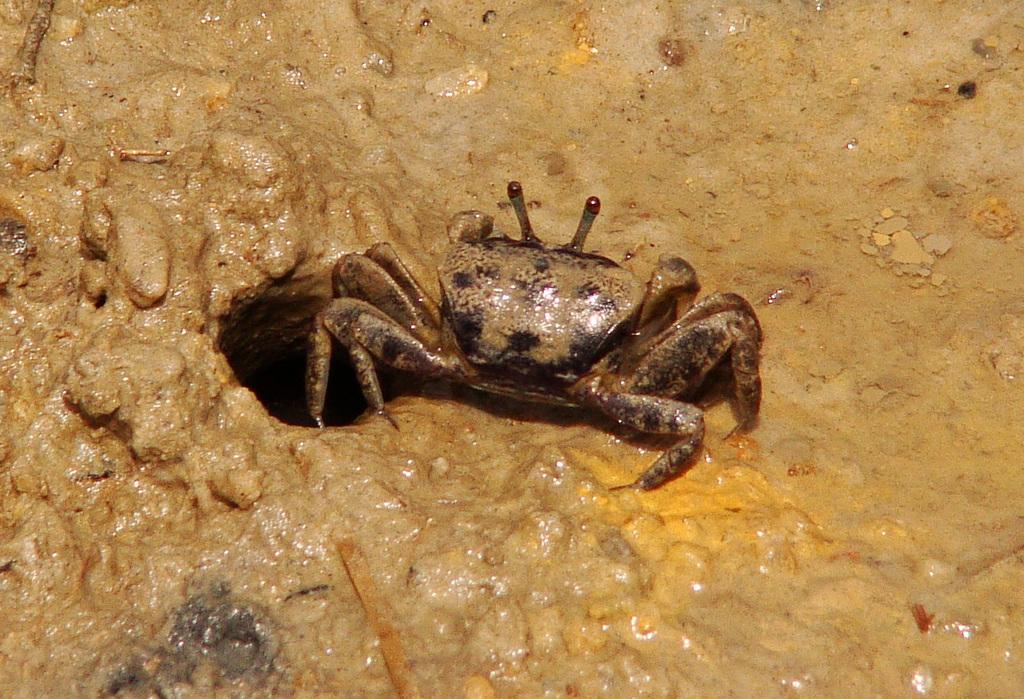What type of creature can be seen in the image? There is an insect in the image. Where is the insect located? The insect is on the mud. What type of respect can be seen in the image? There is no indication of respect in the image, as it features an insect on the mud. What type of wrench is being used by the insect in the image? There is no wrench present in the image, as it features an insect on the mud. 